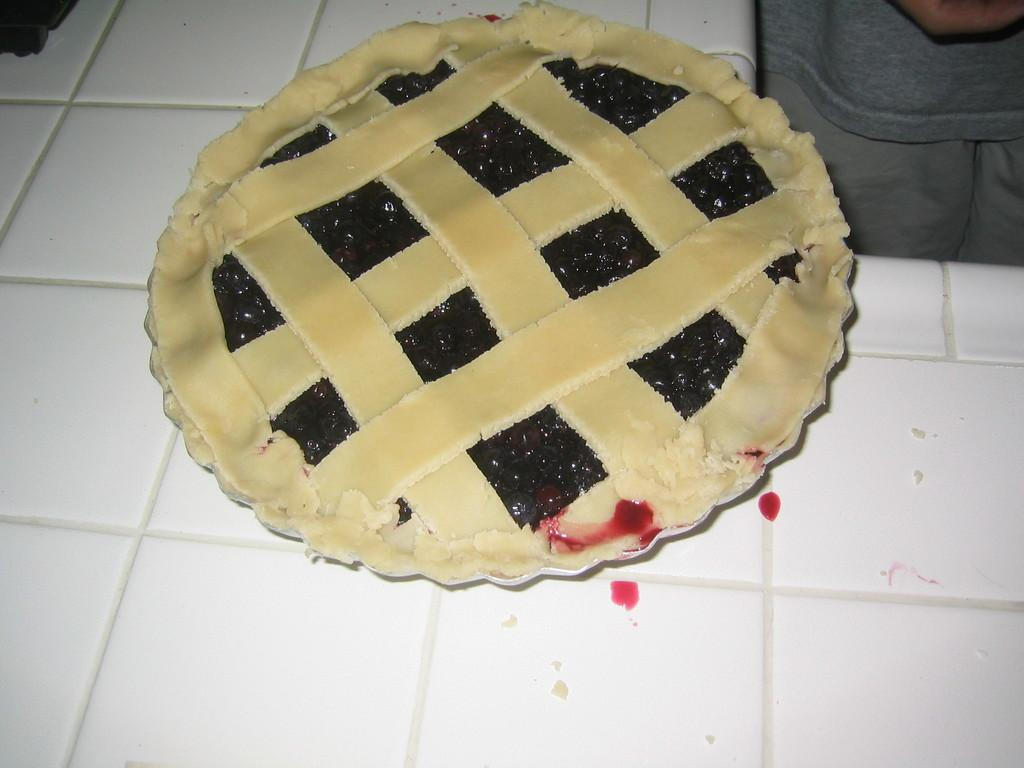What is present in the image? There are food items in the image. On what surface are the food items placed? The food items are placed on a white surface. How many ladybugs can be seen crawling on the food items in the image? There are no ladybugs present in the image; it only features food items placed on a white surface. 